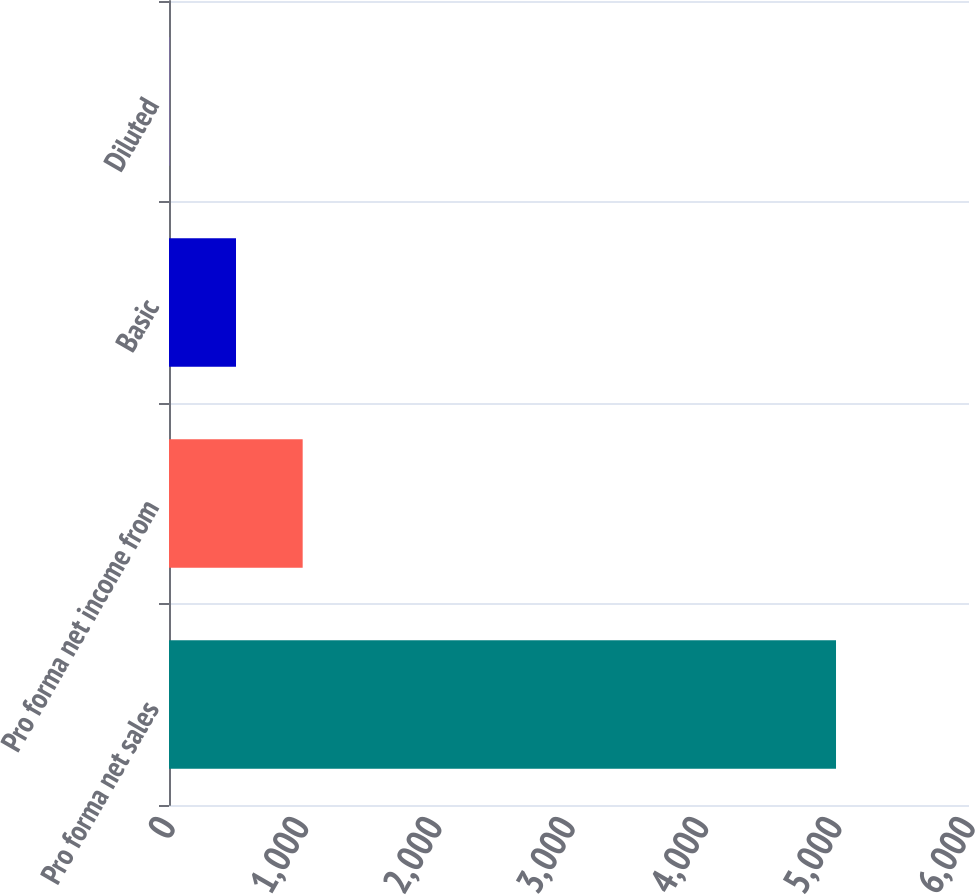<chart> <loc_0><loc_0><loc_500><loc_500><bar_chart><fcel>Pro forma net sales<fcel>Pro forma net income from<fcel>Basic<fcel>Diluted<nl><fcel>5002.6<fcel>1002.54<fcel>502.53<fcel>2.52<nl></chart> 